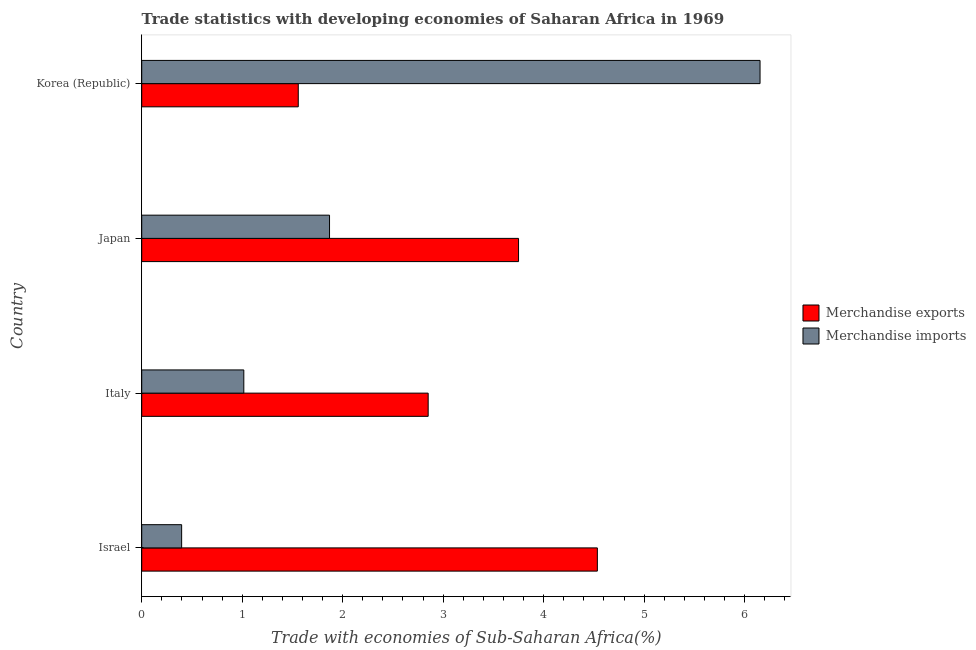How many different coloured bars are there?
Keep it short and to the point. 2. How many groups of bars are there?
Offer a very short reply. 4. Are the number of bars per tick equal to the number of legend labels?
Make the answer very short. Yes. Are the number of bars on each tick of the Y-axis equal?
Provide a succinct answer. Yes. How many bars are there on the 1st tick from the top?
Your response must be concise. 2. How many bars are there on the 2nd tick from the bottom?
Keep it short and to the point. 2. In how many cases, is the number of bars for a given country not equal to the number of legend labels?
Make the answer very short. 0. What is the merchandise exports in Japan?
Your answer should be compact. 3.75. Across all countries, what is the maximum merchandise imports?
Provide a succinct answer. 6.15. Across all countries, what is the minimum merchandise imports?
Make the answer very short. 0.4. In which country was the merchandise exports maximum?
Provide a succinct answer. Israel. In which country was the merchandise exports minimum?
Give a very brief answer. Korea (Republic). What is the total merchandise exports in the graph?
Provide a short and direct response. 12.69. What is the difference between the merchandise imports in Italy and that in Korea (Republic)?
Give a very brief answer. -5.14. What is the difference between the merchandise imports in Japan and the merchandise exports in Italy?
Offer a very short reply. -0.98. What is the average merchandise exports per country?
Provide a short and direct response. 3.17. What is the difference between the merchandise imports and merchandise exports in Korea (Republic)?
Your response must be concise. 4.6. What is the ratio of the merchandise imports in Israel to that in Korea (Republic)?
Make the answer very short. 0.07. Is the merchandise imports in Israel less than that in Italy?
Give a very brief answer. Yes. Is the difference between the merchandise imports in Israel and Japan greater than the difference between the merchandise exports in Israel and Japan?
Your response must be concise. No. What is the difference between the highest and the second highest merchandise exports?
Offer a very short reply. 0.78. What is the difference between the highest and the lowest merchandise exports?
Provide a succinct answer. 2.98. Is the sum of the merchandise imports in Japan and Korea (Republic) greater than the maximum merchandise exports across all countries?
Give a very brief answer. Yes. What does the 1st bar from the bottom in Italy represents?
Make the answer very short. Merchandise exports. How many bars are there?
Ensure brevity in your answer.  8. Are all the bars in the graph horizontal?
Ensure brevity in your answer.  Yes. Are the values on the major ticks of X-axis written in scientific E-notation?
Provide a short and direct response. No. Does the graph contain any zero values?
Offer a very short reply. No. Does the graph contain grids?
Give a very brief answer. No. How many legend labels are there?
Provide a short and direct response. 2. How are the legend labels stacked?
Your response must be concise. Vertical. What is the title of the graph?
Give a very brief answer. Trade statistics with developing economies of Saharan Africa in 1969. What is the label or title of the X-axis?
Ensure brevity in your answer.  Trade with economies of Sub-Saharan Africa(%). What is the Trade with economies of Sub-Saharan Africa(%) in Merchandise exports in Israel?
Provide a succinct answer. 4.53. What is the Trade with economies of Sub-Saharan Africa(%) of Merchandise imports in Israel?
Provide a short and direct response. 0.4. What is the Trade with economies of Sub-Saharan Africa(%) of Merchandise exports in Italy?
Keep it short and to the point. 2.85. What is the Trade with economies of Sub-Saharan Africa(%) in Merchandise imports in Italy?
Provide a succinct answer. 1.02. What is the Trade with economies of Sub-Saharan Africa(%) of Merchandise exports in Japan?
Provide a succinct answer. 3.75. What is the Trade with economies of Sub-Saharan Africa(%) in Merchandise imports in Japan?
Ensure brevity in your answer.  1.87. What is the Trade with economies of Sub-Saharan Africa(%) in Merchandise exports in Korea (Republic)?
Keep it short and to the point. 1.56. What is the Trade with economies of Sub-Saharan Africa(%) of Merchandise imports in Korea (Republic)?
Provide a succinct answer. 6.15. Across all countries, what is the maximum Trade with economies of Sub-Saharan Africa(%) in Merchandise exports?
Give a very brief answer. 4.53. Across all countries, what is the maximum Trade with economies of Sub-Saharan Africa(%) of Merchandise imports?
Your answer should be very brief. 6.15. Across all countries, what is the minimum Trade with economies of Sub-Saharan Africa(%) of Merchandise exports?
Your response must be concise. 1.56. Across all countries, what is the minimum Trade with economies of Sub-Saharan Africa(%) of Merchandise imports?
Offer a very short reply. 0.4. What is the total Trade with economies of Sub-Saharan Africa(%) in Merchandise exports in the graph?
Offer a very short reply. 12.69. What is the total Trade with economies of Sub-Saharan Africa(%) of Merchandise imports in the graph?
Your response must be concise. 9.44. What is the difference between the Trade with economies of Sub-Saharan Africa(%) of Merchandise exports in Israel and that in Italy?
Offer a terse response. 1.68. What is the difference between the Trade with economies of Sub-Saharan Africa(%) of Merchandise imports in Israel and that in Italy?
Provide a short and direct response. -0.62. What is the difference between the Trade with economies of Sub-Saharan Africa(%) of Merchandise exports in Israel and that in Japan?
Your answer should be compact. 0.78. What is the difference between the Trade with economies of Sub-Saharan Africa(%) of Merchandise imports in Israel and that in Japan?
Provide a succinct answer. -1.47. What is the difference between the Trade with economies of Sub-Saharan Africa(%) of Merchandise exports in Israel and that in Korea (Republic)?
Ensure brevity in your answer.  2.98. What is the difference between the Trade with economies of Sub-Saharan Africa(%) of Merchandise imports in Israel and that in Korea (Republic)?
Offer a terse response. -5.76. What is the difference between the Trade with economies of Sub-Saharan Africa(%) in Merchandise exports in Italy and that in Japan?
Give a very brief answer. -0.9. What is the difference between the Trade with economies of Sub-Saharan Africa(%) of Merchandise imports in Italy and that in Japan?
Offer a terse response. -0.85. What is the difference between the Trade with economies of Sub-Saharan Africa(%) of Merchandise exports in Italy and that in Korea (Republic)?
Your response must be concise. 1.29. What is the difference between the Trade with economies of Sub-Saharan Africa(%) of Merchandise imports in Italy and that in Korea (Republic)?
Your response must be concise. -5.14. What is the difference between the Trade with economies of Sub-Saharan Africa(%) of Merchandise exports in Japan and that in Korea (Republic)?
Offer a terse response. 2.19. What is the difference between the Trade with economies of Sub-Saharan Africa(%) of Merchandise imports in Japan and that in Korea (Republic)?
Offer a terse response. -4.28. What is the difference between the Trade with economies of Sub-Saharan Africa(%) in Merchandise exports in Israel and the Trade with economies of Sub-Saharan Africa(%) in Merchandise imports in Italy?
Keep it short and to the point. 3.52. What is the difference between the Trade with economies of Sub-Saharan Africa(%) of Merchandise exports in Israel and the Trade with economies of Sub-Saharan Africa(%) of Merchandise imports in Japan?
Keep it short and to the point. 2.67. What is the difference between the Trade with economies of Sub-Saharan Africa(%) in Merchandise exports in Israel and the Trade with economies of Sub-Saharan Africa(%) in Merchandise imports in Korea (Republic)?
Your answer should be very brief. -1.62. What is the difference between the Trade with economies of Sub-Saharan Africa(%) in Merchandise exports in Italy and the Trade with economies of Sub-Saharan Africa(%) in Merchandise imports in Japan?
Your answer should be very brief. 0.98. What is the difference between the Trade with economies of Sub-Saharan Africa(%) in Merchandise exports in Italy and the Trade with economies of Sub-Saharan Africa(%) in Merchandise imports in Korea (Republic)?
Your answer should be compact. -3.3. What is the difference between the Trade with economies of Sub-Saharan Africa(%) of Merchandise exports in Japan and the Trade with economies of Sub-Saharan Africa(%) of Merchandise imports in Korea (Republic)?
Provide a short and direct response. -2.4. What is the average Trade with economies of Sub-Saharan Africa(%) of Merchandise exports per country?
Provide a succinct answer. 3.17. What is the average Trade with economies of Sub-Saharan Africa(%) in Merchandise imports per country?
Offer a very short reply. 2.36. What is the difference between the Trade with economies of Sub-Saharan Africa(%) of Merchandise exports and Trade with economies of Sub-Saharan Africa(%) of Merchandise imports in Israel?
Offer a very short reply. 4.14. What is the difference between the Trade with economies of Sub-Saharan Africa(%) in Merchandise exports and Trade with economies of Sub-Saharan Africa(%) in Merchandise imports in Italy?
Ensure brevity in your answer.  1.83. What is the difference between the Trade with economies of Sub-Saharan Africa(%) in Merchandise exports and Trade with economies of Sub-Saharan Africa(%) in Merchandise imports in Japan?
Give a very brief answer. 1.88. What is the difference between the Trade with economies of Sub-Saharan Africa(%) in Merchandise exports and Trade with economies of Sub-Saharan Africa(%) in Merchandise imports in Korea (Republic)?
Offer a very short reply. -4.6. What is the ratio of the Trade with economies of Sub-Saharan Africa(%) of Merchandise exports in Israel to that in Italy?
Keep it short and to the point. 1.59. What is the ratio of the Trade with economies of Sub-Saharan Africa(%) of Merchandise imports in Israel to that in Italy?
Provide a short and direct response. 0.39. What is the ratio of the Trade with economies of Sub-Saharan Africa(%) of Merchandise exports in Israel to that in Japan?
Ensure brevity in your answer.  1.21. What is the ratio of the Trade with economies of Sub-Saharan Africa(%) of Merchandise imports in Israel to that in Japan?
Your response must be concise. 0.21. What is the ratio of the Trade with economies of Sub-Saharan Africa(%) of Merchandise exports in Israel to that in Korea (Republic)?
Make the answer very short. 2.91. What is the ratio of the Trade with economies of Sub-Saharan Africa(%) in Merchandise imports in Israel to that in Korea (Republic)?
Make the answer very short. 0.06. What is the ratio of the Trade with economies of Sub-Saharan Africa(%) of Merchandise exports in Italy to that in Japan?
Your response must be concise. 0.76. What is the ratio of the Trade with economies of Sub-Saharan Africa(%) of Merchandise imports in Italy to that in Japan?
Offer a terse response. 0.54. What is the ratio of the Trade with economies of Sub-Saharan Africa(%) of Merchandise exports in Italy to that in Korea (Republic)?
Your response must be concise. 1.83. What is the ratio of the Trade with economies of Sub-Saharan Africa(%) in Merchandise imports in Italy to that in Korea (Republic)?
Provide a short and direct response. 0.17. What is the ratio of the Trade with economies of Sub-Saharan Africa(%) of Merchandise exports in Japan to that in Korea (Republic)?
Your response must be concise. 2.41. What is the ratio of the Trade with economies of Sub-Saharan Africa(%) of Merchandise imports in Japan to that in Korea (Republic)?
Give a very brief answer. 0.3. What is the difference between the highest and the second highest Trade with economies of Sub-Saharan Africa(%) in Merchandise exports?
Your answer should be very brief. 0.78. What is the difference between the highest and the second highest Trade with economies of Sub-Saharan Africa(%) of Merchandise imports?
Offer a very short reply. 4.28. What is the difference between the highest and the lowest Trade with economies of Sub-Saharan Africa(%) of Merchandise exports?
Provide a succinct answer. 2.98. What is the difference between the highest and the lowest Trade with economies of Sub-Saharan Africa(%) in Merchandise imports?
Your answer should be very brief. 5.76. 